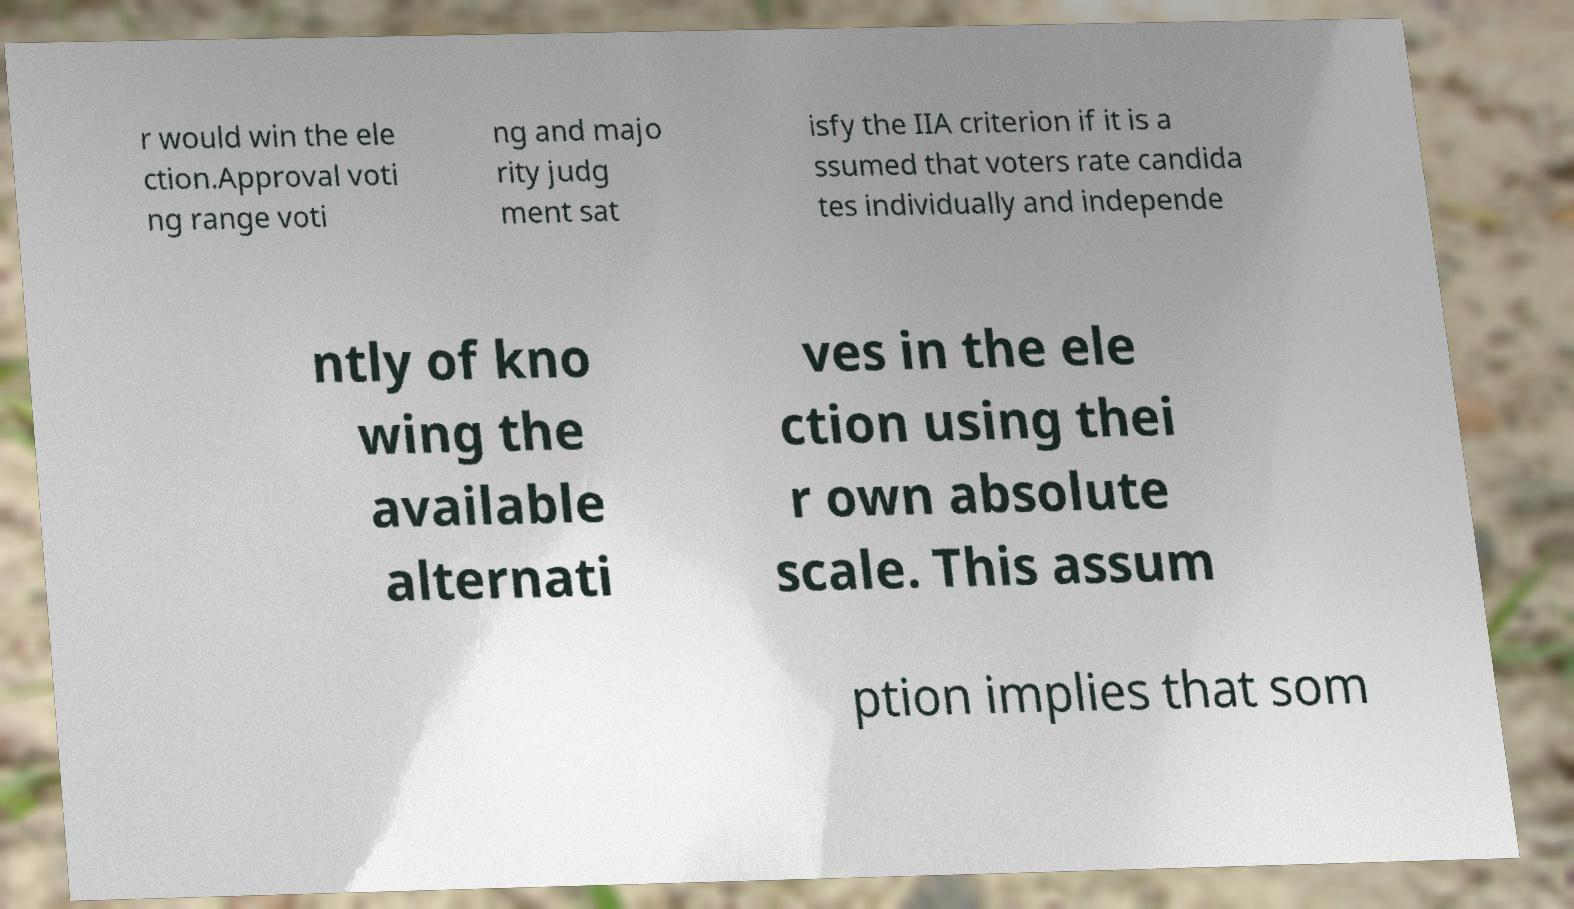There's text embedded in this image that I need extracted. Can you transcribe it verbatim? r would win the ele ction.Approval voti ng range voti ng and majo rity judg ment sat isfy the IIA criterion if it is a ssumed that voters rate candida tes individually and independe ntly of kno wing the available alternati ves in the ele ction using thei r own absolute scale. This assum ption implies that som 